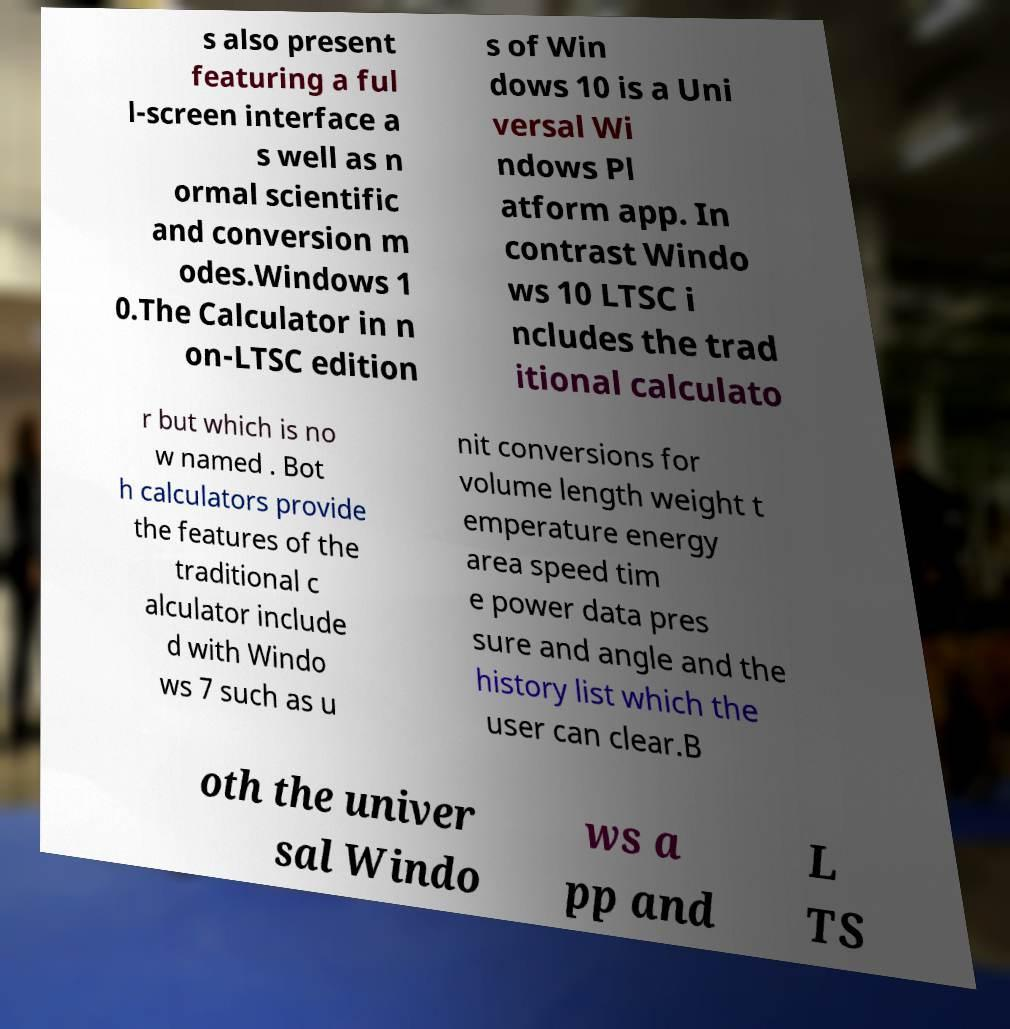What messages or text are displayed in this image? I need them in a readable, typed format. s also present featuring a ful l-screen interface a s well as n ormal scientific and conversion m odes.Windows 1 0.The Calculator in n on-LTSC edition s of Win dows 10 is a Uni versal Wi ndows Pl atform app. In contrast Windo ws 10 LTSC i ncludes the trad itional calculato r but which is no w named . Bot h calculators provide the features of the traditional c alculator include d with Windo ws 7 such as u nit conversions for volume length weight t emperature energy area speed tim e power data pres sure and angle and the history list which the user can clear.B oth the univer sal Windo ws a pp and L TS 